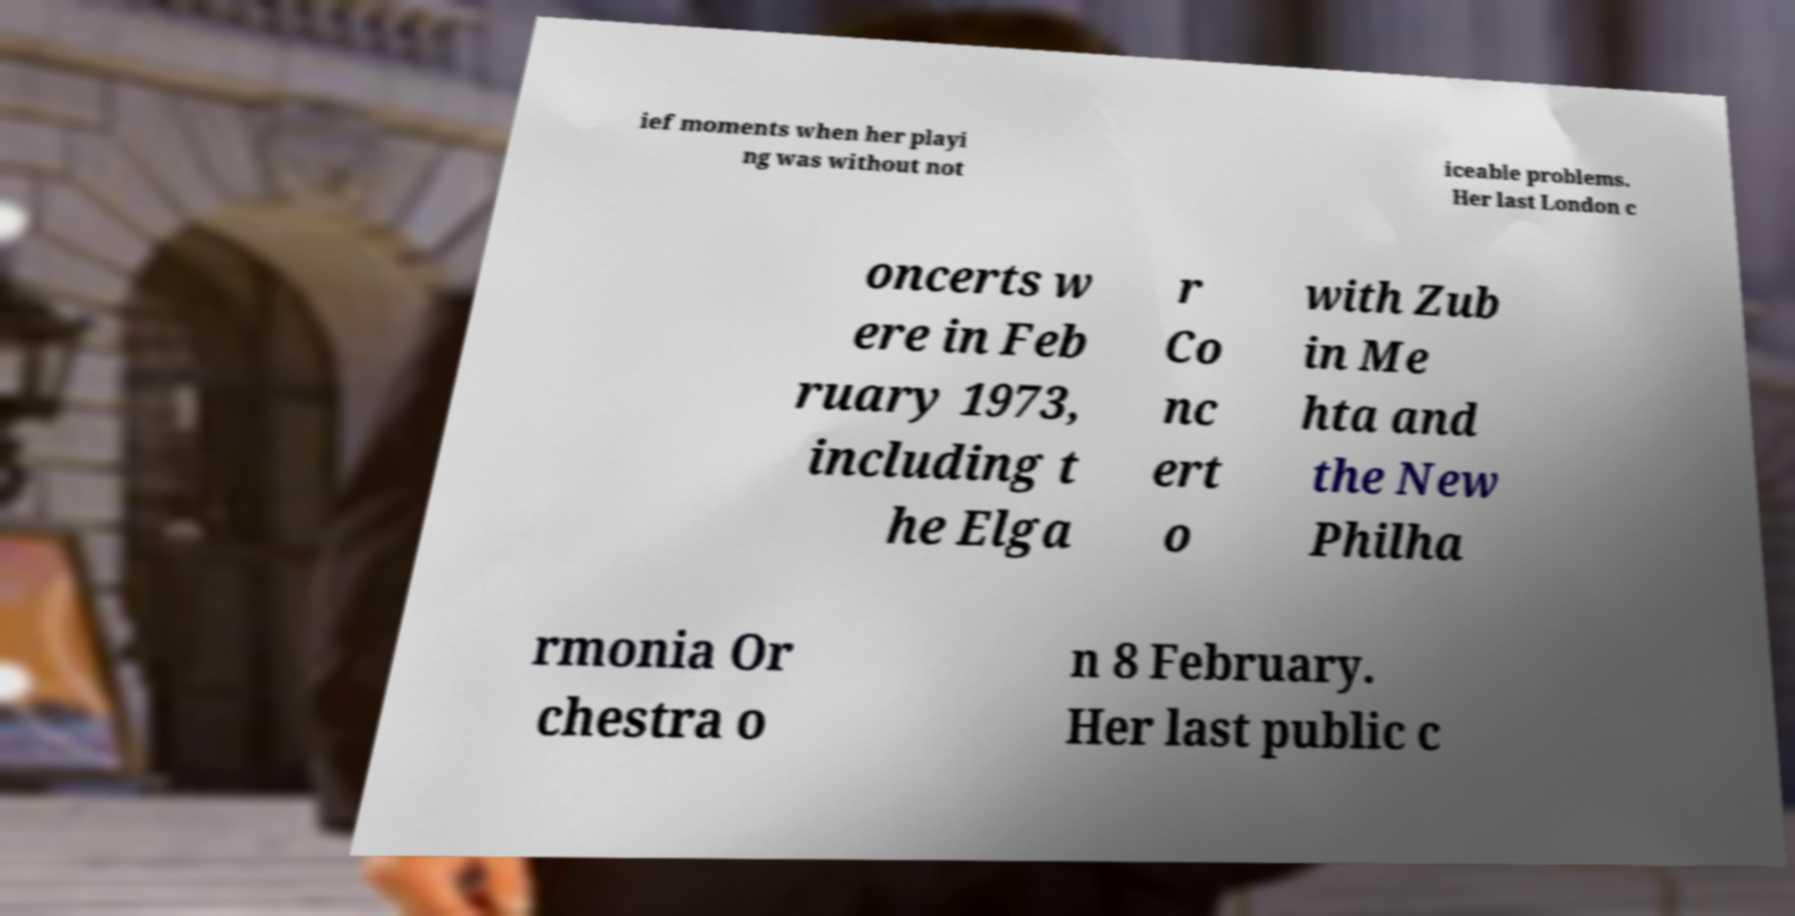For documentation purposes, I need the text within this image transcribed. Could you provide that? ief moments when her playi ng was without not iceable problems. Her last London c oncerts w ere in Feb ruary 1973, including t he Elga r Co nc ert o with Zub in Me hta and the New Philha rmonia Or chestra o n 8 February. Her last public c 